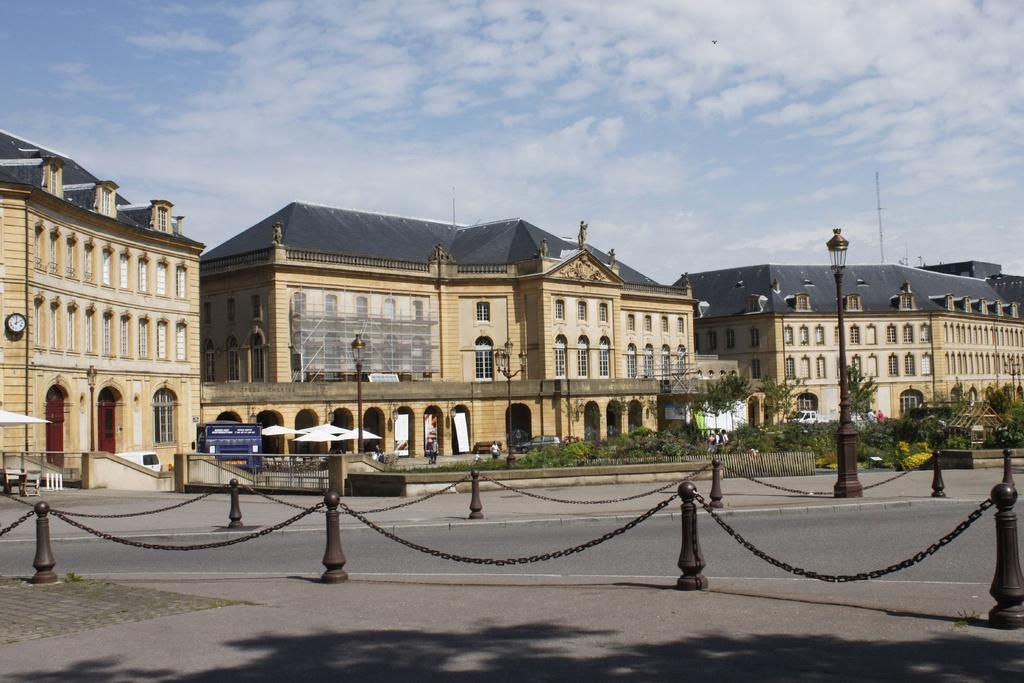What type of railings can be seen in the image? There are chain railings in the image. What structures are present in the image? There are light poles, buildings, and a fence in the image. What type of vegetation is visible in the image? There are trees and plants in the image. What objects can be seen in the image? There are umbrellas, boards, and a clock in the image. What is the weather like in the image? The sky is cloudy in the image. Are there any living beings in the image? Yes, there are people in the image. What is the caption of the image? There is no caption present in the image. How many snails can be seen crawling on the buildings in the image? There are no snails visible in the image. 